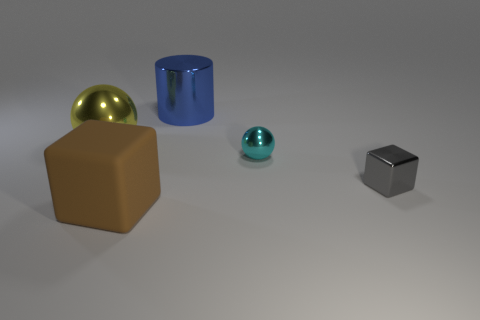Add 3 small cyan shiny cubes. How many objects exist? 8 Subtract all cubes. How many objects are left? 3 Subtract all large brown matte blocks. Subtract all metallic cylinders. How many objects are left? 3 Add 5 cyan things. How many cyan things are left? 6 Add 4 large blue cylinders. How many large blue cylinders exist? 5 Subtract 0 blue balls. How many objects are left? 5 Subtract 1 cubes. How many cubes are left? 1 Subtract all purple cylinders. Subtract all purple spheres. How many cylinders are left? 1 Subtract all purple cubes. How many brown balls are left? 0 